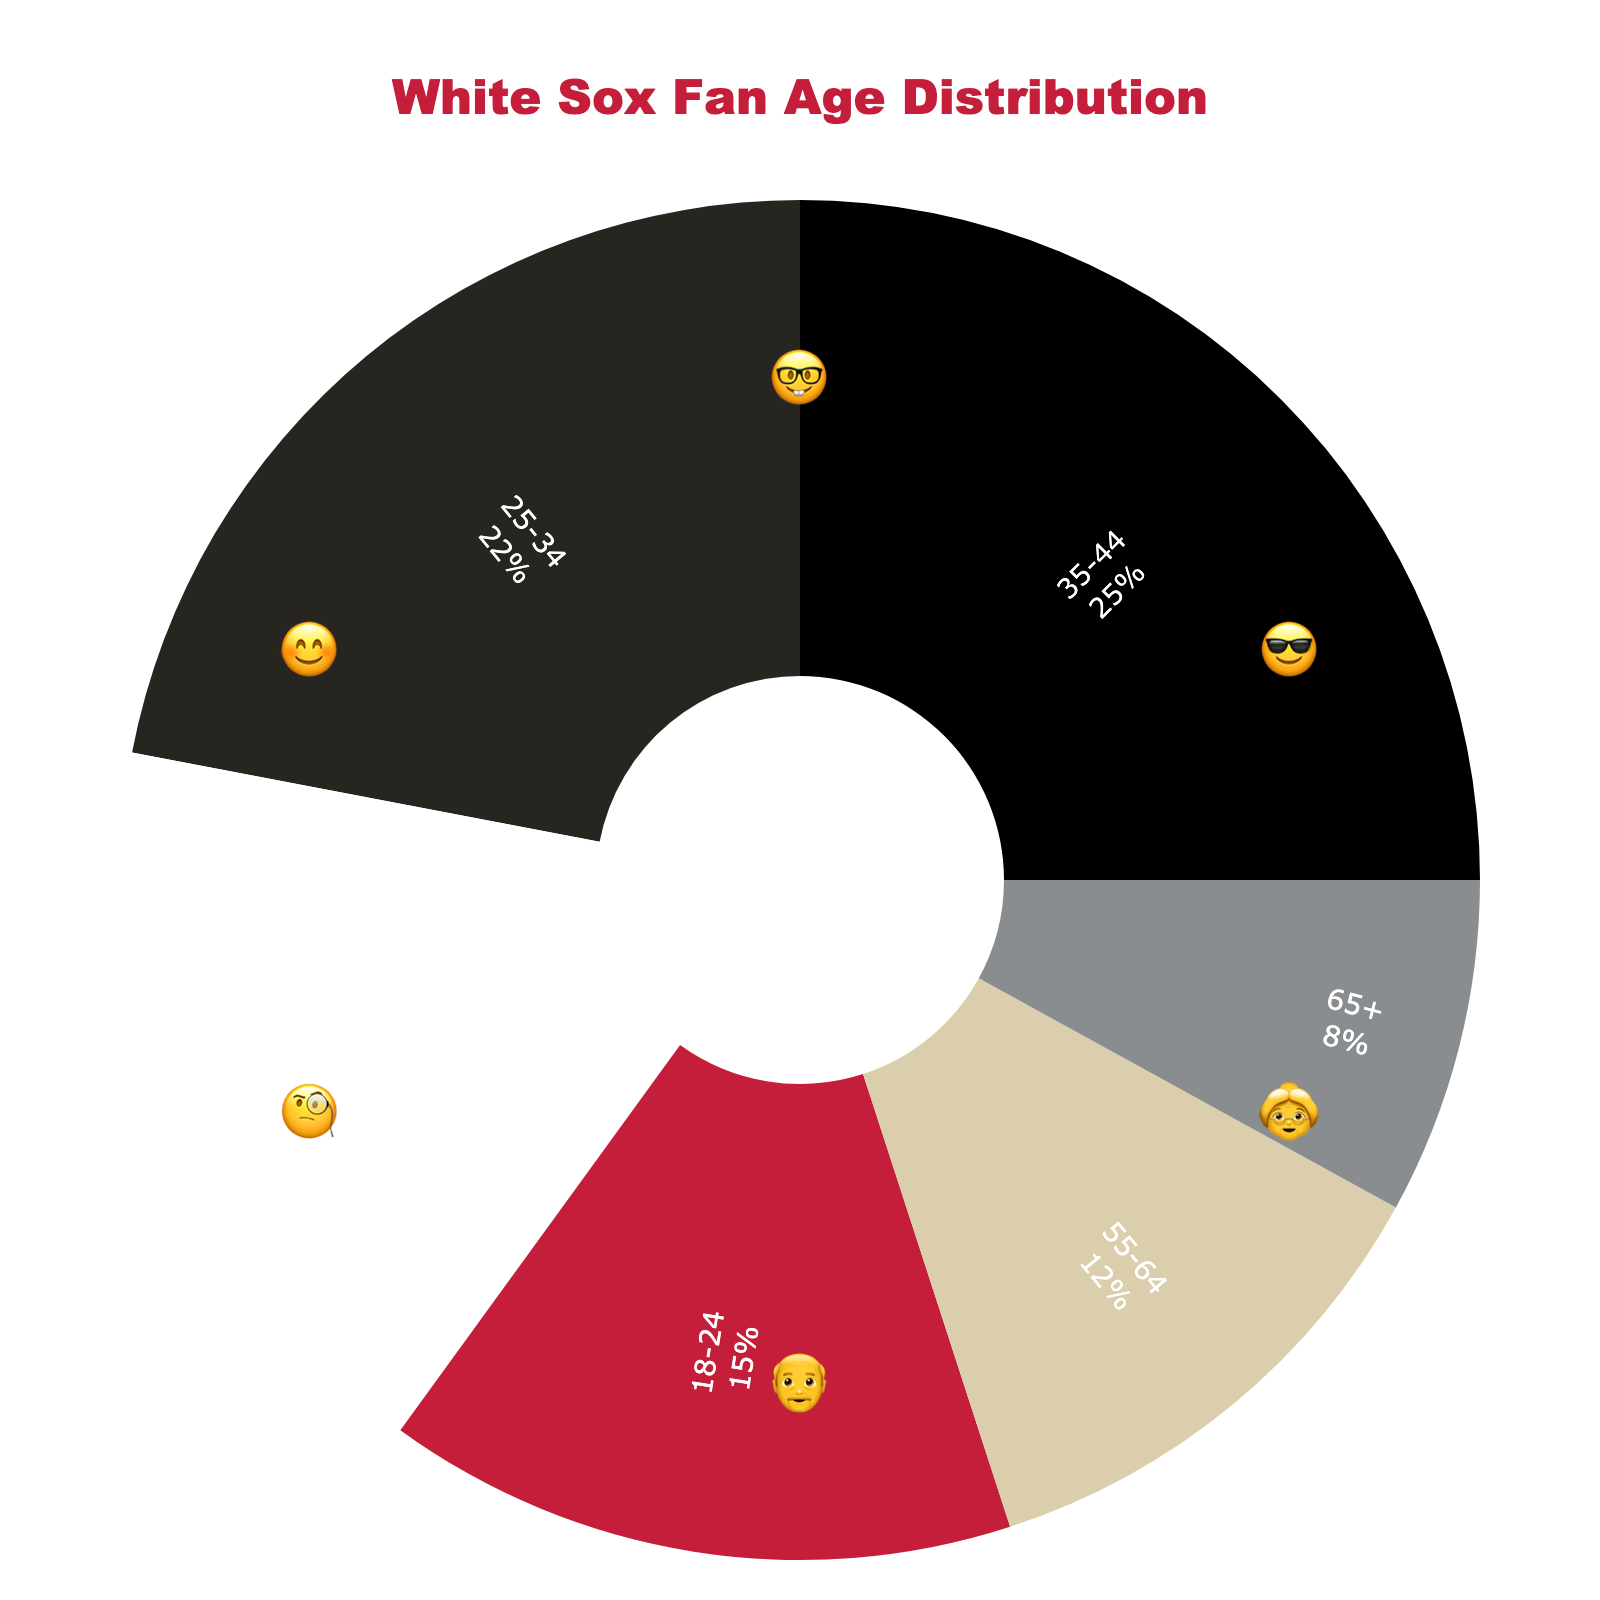Which age group has the highest percentage among White Sox fans? Locate the age group with the largest slice in the pie chart. The age group 35-44 is the largest at 25%.
Answer: 35-44 Which emoji represents the 25-34 age group? Identify the emoji next to the age group 25-34 in the chart. It's the emoji with glasses (🤓).
Answer: 🤓 What is the sum of percentages for the 18-24 and 65+ age groups? Add the percentages of these two age groups: 15% (18-24) and 8% (65+). The sum is 15 + 8 = 23%.
Answer: 23% Which age group has the smallest representation? Find the smallest slice in the pie chart. The age group 65+ has the smallest percentage, at 8%.
Answer: 65+ Between the 45-54 and 55-64 age groups, which has a higher percentage? Look at the pie chart to compare the slices for these two groups. The 45-54 group has 18%, and the 55-64 group has 12%. Therefore, 45-54 is higher.
Answer: 45-54 Which two age groups are represented by the 'old' emojis? Locate the age groups with the 'old' emojis. The age groups 55-64 and 65+ are represented by the grandpa (👴) and grandma (👵) emojis.
Answer: 55-64 and 65+ How much more is the percentage of the 35-44 age group compared to the 18-24 age group? Subtract the percentage of the 18-24 group from the 35-44 group: 25% - 15%. The difference is 10%.
Answer: 10% What is the total percentage represented by age groups below 35? Add the percentages of the 18-24 and 25-34 age groups: 15% (18-24) + 22% (25-34) = 37%.
Answer: 37% What is the average percentage for all the age groups in the chart? Sum all age group percentages and then divide by the number of age groups (6). (15 + 22 + 25 + 18 + 12 + 8) / 6 = 100 / 6 = 16.67%.
Answer: 16.67% What is the title of the figure? Read the title at the top of the chart. It says "White Sox Fan Age Distribution."
Answer: White Sox Fan Age Distribution 